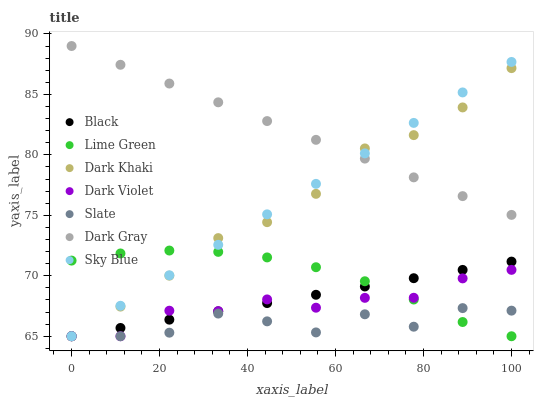Does Slate have the minimum area under the curve?
Answer yes or no. Yes. Does Dark Gray have the maximum area under the curve?
Answer yes or no. Yes. Does Dark Violet have the minimum area under the curve?
Answer yes or no. No. Does Dark Violet have the maximum area under the curve?
Answer yes or no. No. Is Black the smoothest?
Answer yes or no. Yes. Is Slate the roughest?
Answer yes or no. Yes. Is Dark Violet the smoothest?
Answer yes or no. No. Is Dark Violet the roughest?
Answer yes or no. No. Does Slate have the lowest value?
Answer yes or no. Yes. Does Dark Gray have the highest value?
Answer yes or no. Yes. Does Dark Violet have the highest value?
Answer yes or no. No. Is Dark Violet less than Dark Gray?
Answer yes or no. Yes. Is Dark Gray greater than Black?
Answer yes or no. Yes. Does Sky Blue intersect Dark Gray?
Answer yes or no. Yes. Is Sky Blue less than Dark Gray?
Answer yes or no. No. Is Sky Blue greater than Dark Gray?
Answer yes or no. No. Does Dark Violet intersect Dark Gray?
Answer yes or no. No. 